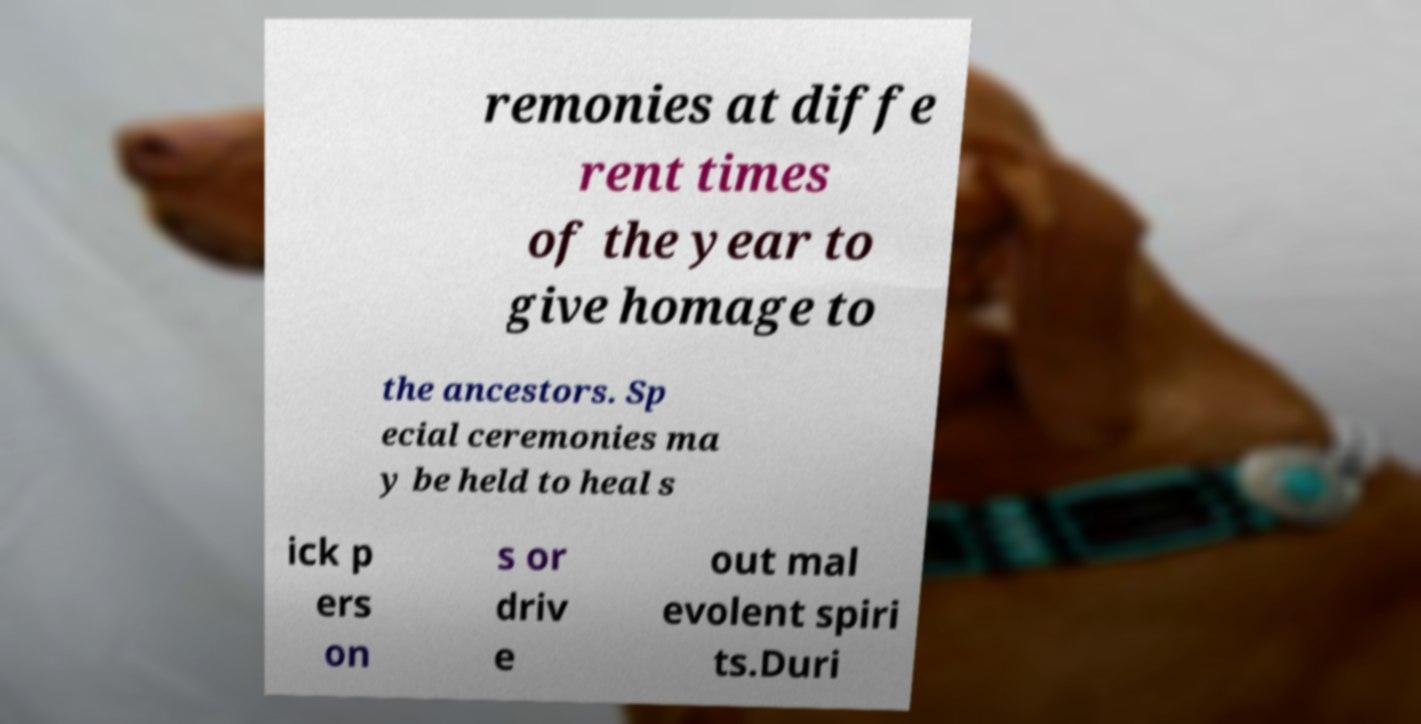What messages or text are displayed in this image? I need them in a readable, typed format. remonies at diffe rent times of the year to give homage to the ancestors. Sp ecial ceremonies ma y be held to heal s ick p ers on s or driv e out mal evolent spiri ts.Duri 